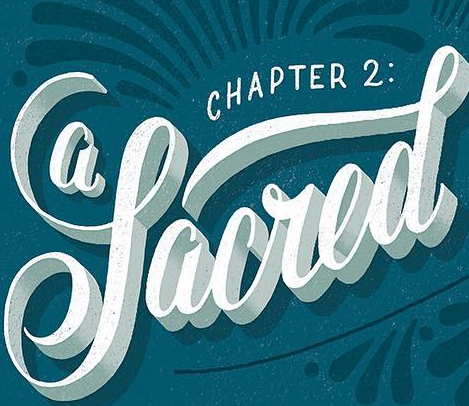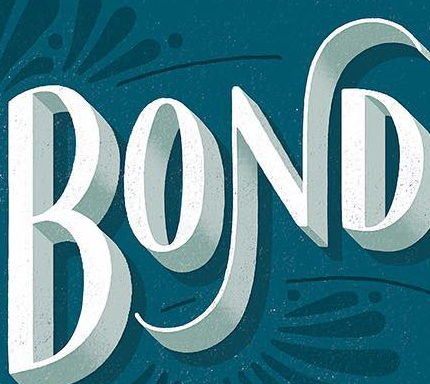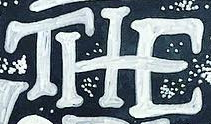What words are shown in these images in order, separated by a semicolon? Sacred; BOND; THE 